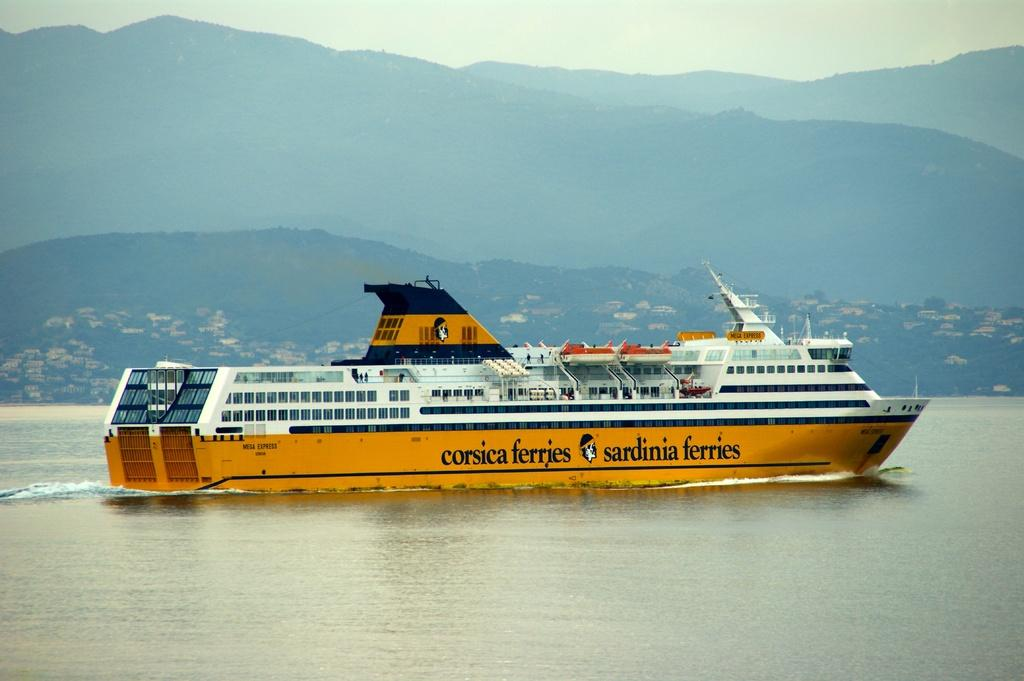What is the main subject of the image? The main subject of the image is a ship in the water. What can be seen on the ship? The ship has windows and writing on it. What is visible in the background of the image? There are hills and the sky visible in the background of the image. What type of bottle is being driven by the ship in the image? There is no bottle or driving activity present in the image; it features a ship in the water with windows and writing. What is the mysterious thing floating in the water next to the ship in the image? There is no mysterious thing floating in the water next to the ship in the image; only the ship, water, hills, and sky are present. 